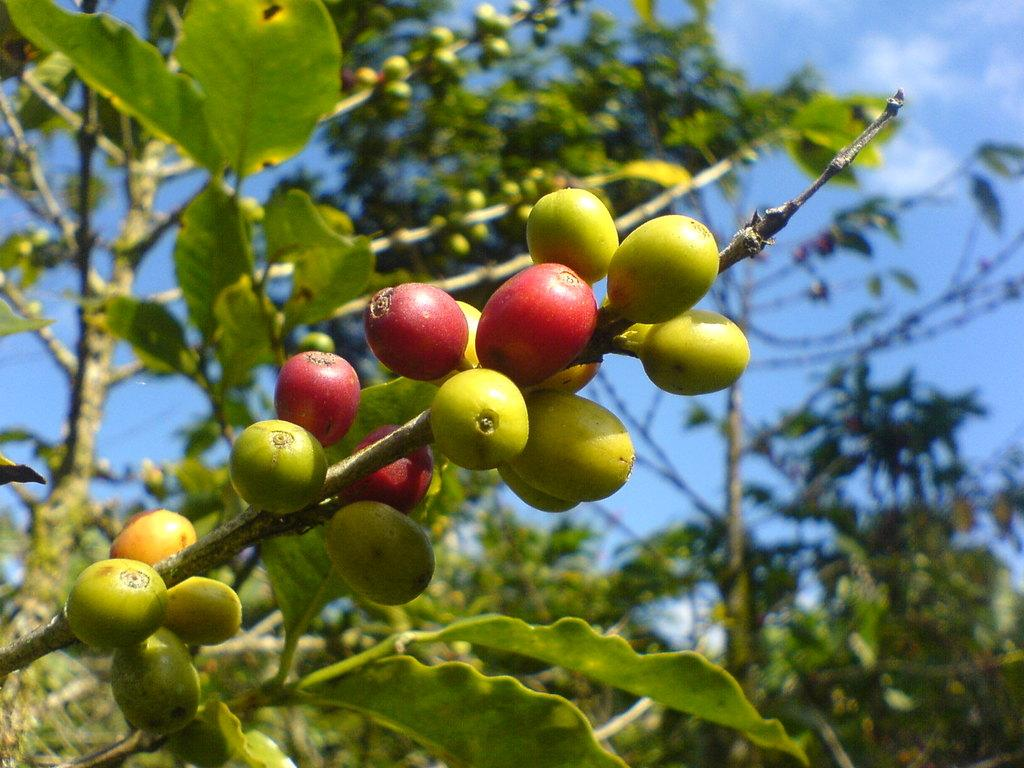What type of objects are attached to a stem in the image? There are fruits attached to a stem in the image. What can be seen in the background of the image? There are trees and the sky visible in the background of the image. What type of sweater is the mother wearing in the image? There is no mother or sweater present in the image; it features fruits attached to a stem and a background with trees and the sky. 